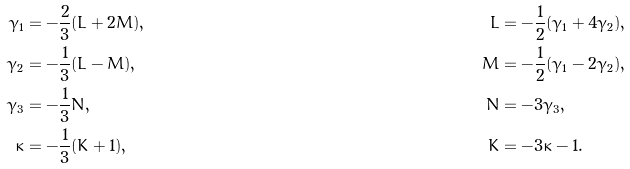<formula> <loc_0><loc_0><loc_500><loc_500>\gamma _ { 1 } & = - \frac { 2 } { 3 } ( L + 2 M ) , & L & = - \frac { 1 } { 2 } ( \gamma _ { 1 } + 4 \gamma _ { 2 } ) , \\ \gamma _ { 2 } & = - \frac { 1 } { 3 } ( L - M ) , & M & = - \frac { 1 } { 2 } ( \gamma _ { 1 } - 2 \gamma _ { 2 } ) , \\ \gamma _ { 3 } & = - \frac { 1 } { 3 } N , & N & = - 3 \gamma _ { 3 } , \\ \kappa & = - \frac { 1 } { 3 } ( K + 1 ) , & K & = - 3 \kappa - 1 .</formula> 